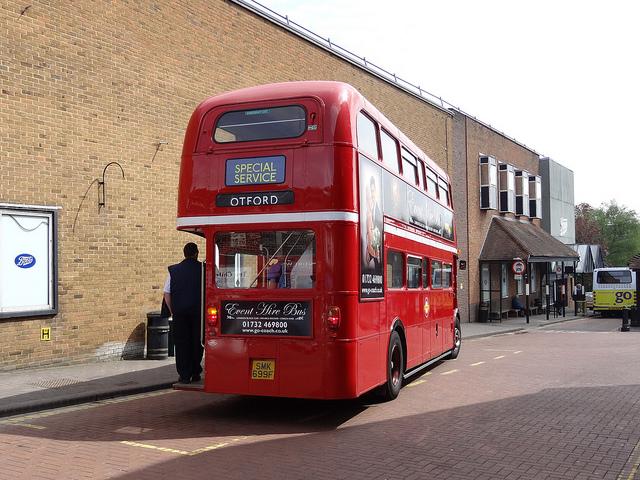Where is the bus going?
Answer briefly. Otford. How many levels does this bus have?
Write a very short answer. 2. Is the building tall?
Give a very brief answer. Yes. 